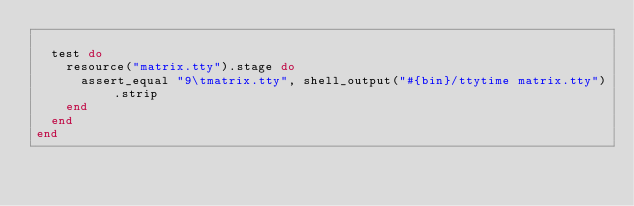Convert code to text. <code><loc_0><loc_0><loc_500><loc_500><_Ruby_>
  test do
    resource("matrix.tty").stage do
      assert_equal "9\tmatrix.tty", shell_output("#{bin}/ttytime matrix.tty").strip
    end
  end
end
</code> 